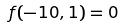Convert formula to latex. <formula><loc_0><loc_0><loc_500><loc_500>f ( - 1 0 , 1 ) = 0</formula> 